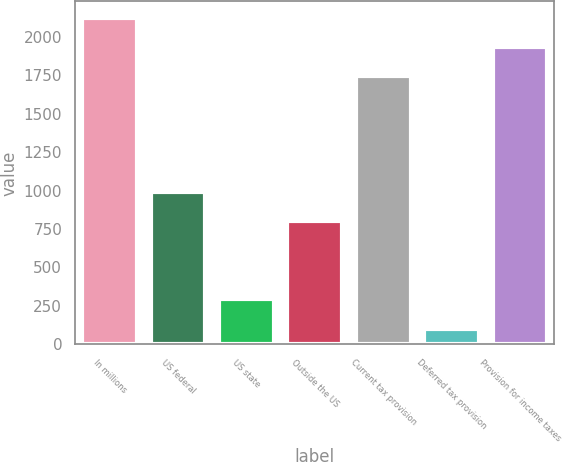Convert chart to OTSL. <chart><loc_0><loc_0><loc_500><loc_500><bar_chart><fcel>In millions<fcel>US federal<fcel>US state<fcel>Outside the US<fcel>Current tax provision<fcel>Deferred tax provision<fcel>Provision for income taxes<nl><fcel>2124.6<fcel>990.85<fcel>292.15<fcel>800.2<fcel>1743.3<fcel>101.5<fcel>1933.95<nl></chart> 